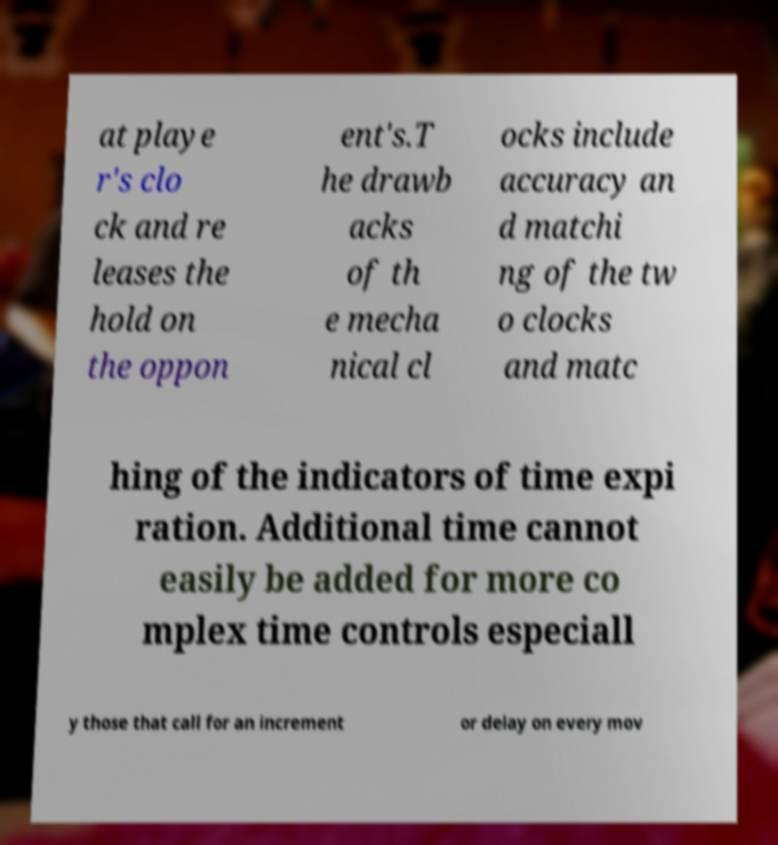There's text embedded in this image that I need extracted. Can you transcribe it verbatim? at playe r's clo ck and re leases the hold on the oppon ent's.T he drawb acks of th e mecha nical cl ocks include accuracy an d matchi ng of the tw o clocks and matc hing of the indicators of time expi ration. Additional time cannot easily be added for more co mplex time controls especiall y those that call for an increment or delay on every mov 